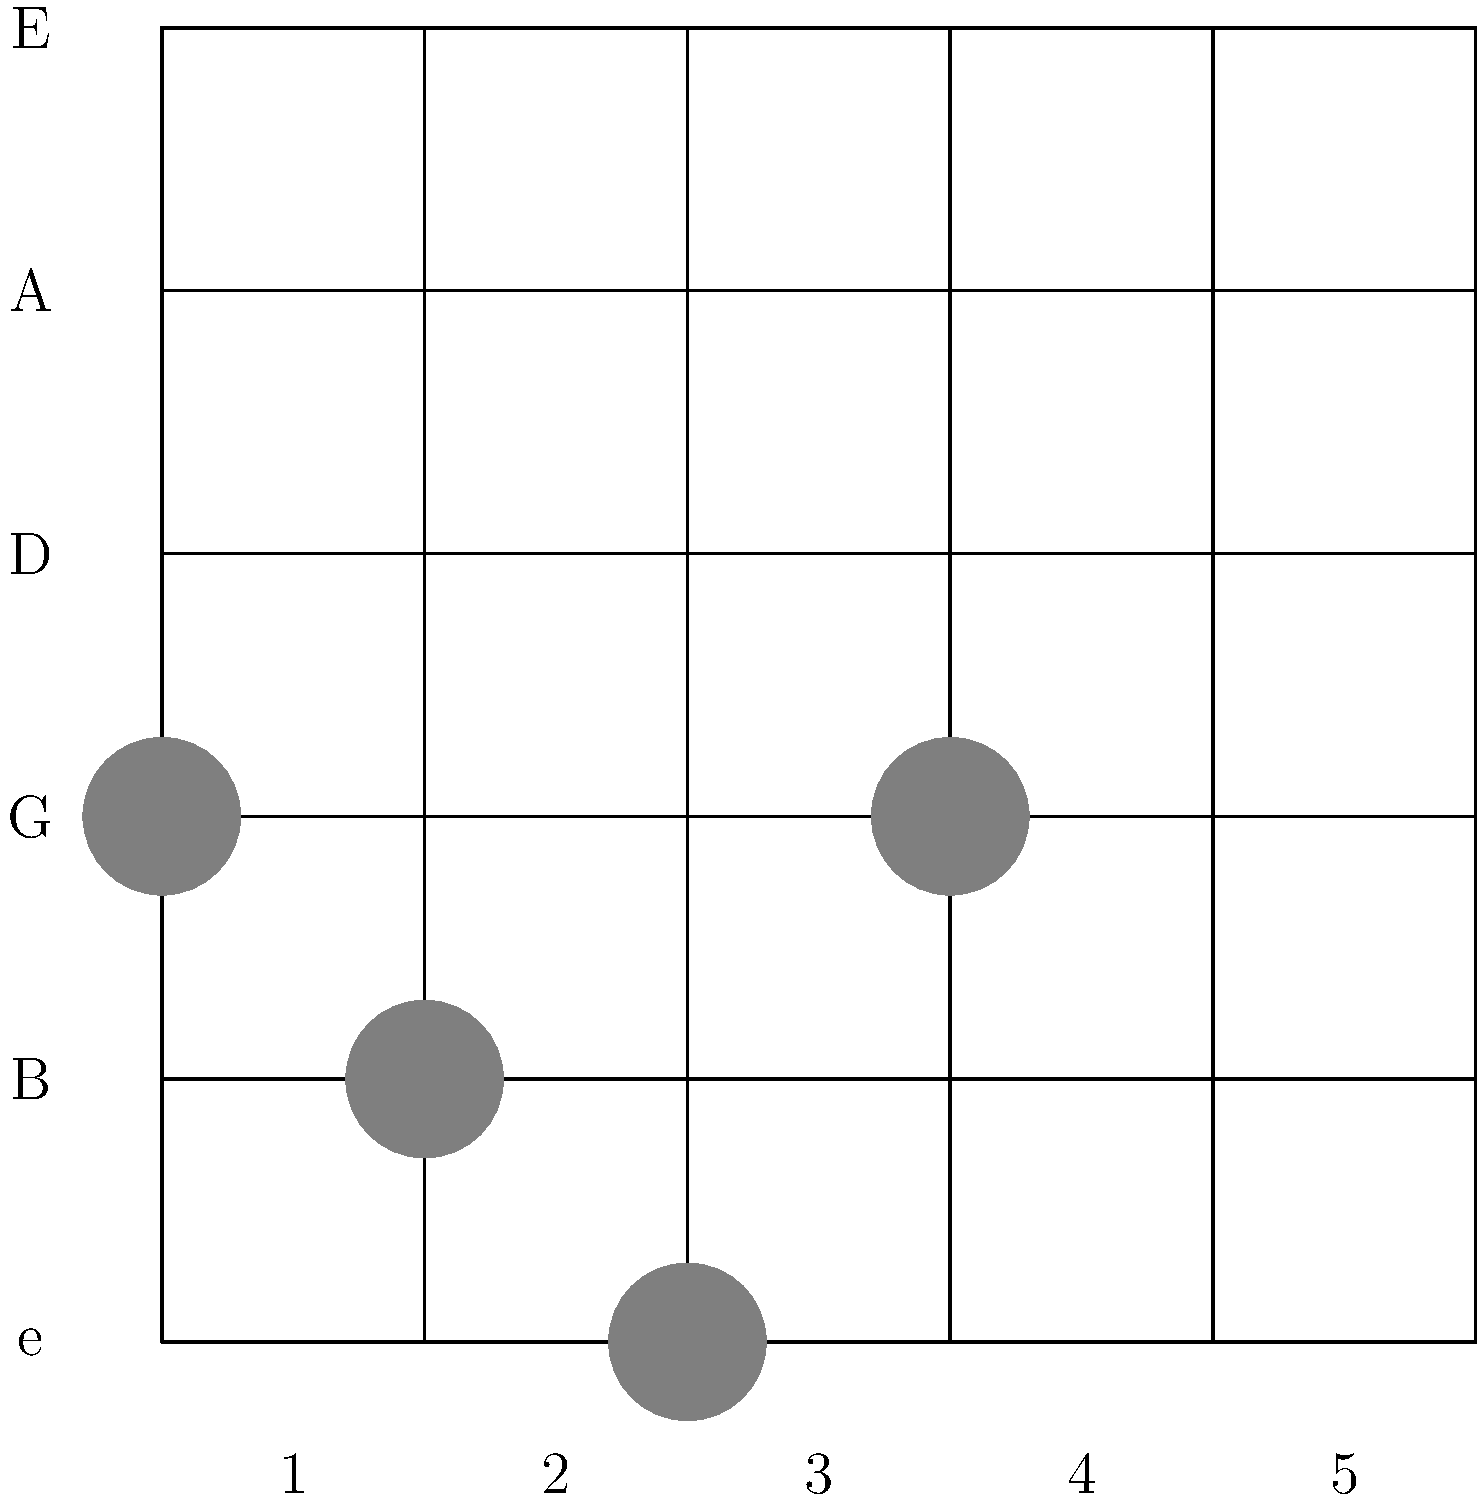Identify the chord shape shown on the fretboard diagram. This chord shape is commonly used by John Frusciante in many Red Hot Chili Peppers songs, especially during his melodic rhythm playing. To identify this chord shape, let's analyze it step-by-step:

1. The diagram shows a 6-string guitar fretboard with 5 frets.
2. The filled circles indicate where fingers should be placed.
3. The chord shape shows:
   - 3rd fret on the G string (3rd string from the bottom)
   - 2nd fret on the D string (4th string from the bottom)
   - 1st fret on the B string (2nd string from the bottom)
   - Open high E string (1st string from the bottom)
   - The low E and A strings (6th and 5th strings) are not played

4. This finger placement forms the shape of a major chord.
5. The root note of this chord is on the 3rd fret of the G string, which is a B note.

Therefore, this chord shape represents a B major chord in its first inversion (with the 3rd in the bass). This shape is known as the "Hendrix chord" or "7#9 chord" when played with the root on the A string, but in this case, it's just a standard major chord shape.

John Frusciante frequently uses this chord shape in his playing with Red Hot Chili Peppers, often as part of his signature melodic rhythm guitar style. It can be heard in songs like "Under the Bridge" and "Scar Tissue."
Answer: B major (1st inversion) 